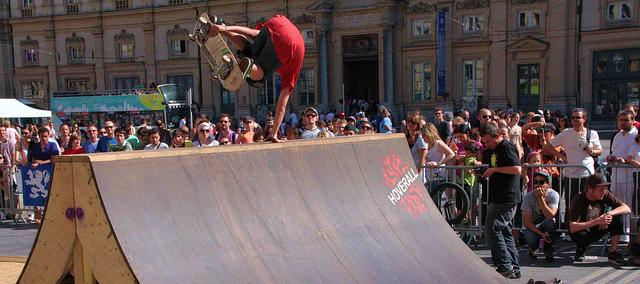What maneuver is the man wearing red performing? Please explain your reasoning. hand plant. The man's hand is placed on top of the ramp in a manner that would be done when intentionally performing a trick known as answer a. 